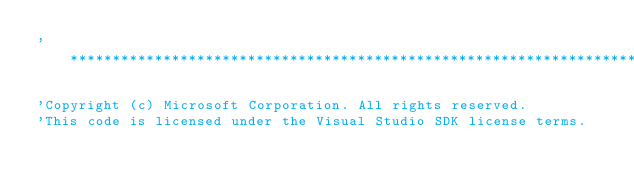<code> <loc_0><loc_0><loc_500><loc_500><_VisualBasic_>'**************************************************************************

'Copyright (c) Microsoft Corporation. All rights reserved.
'This code is licensed under the Visual Studio SDK license terms.</code> 